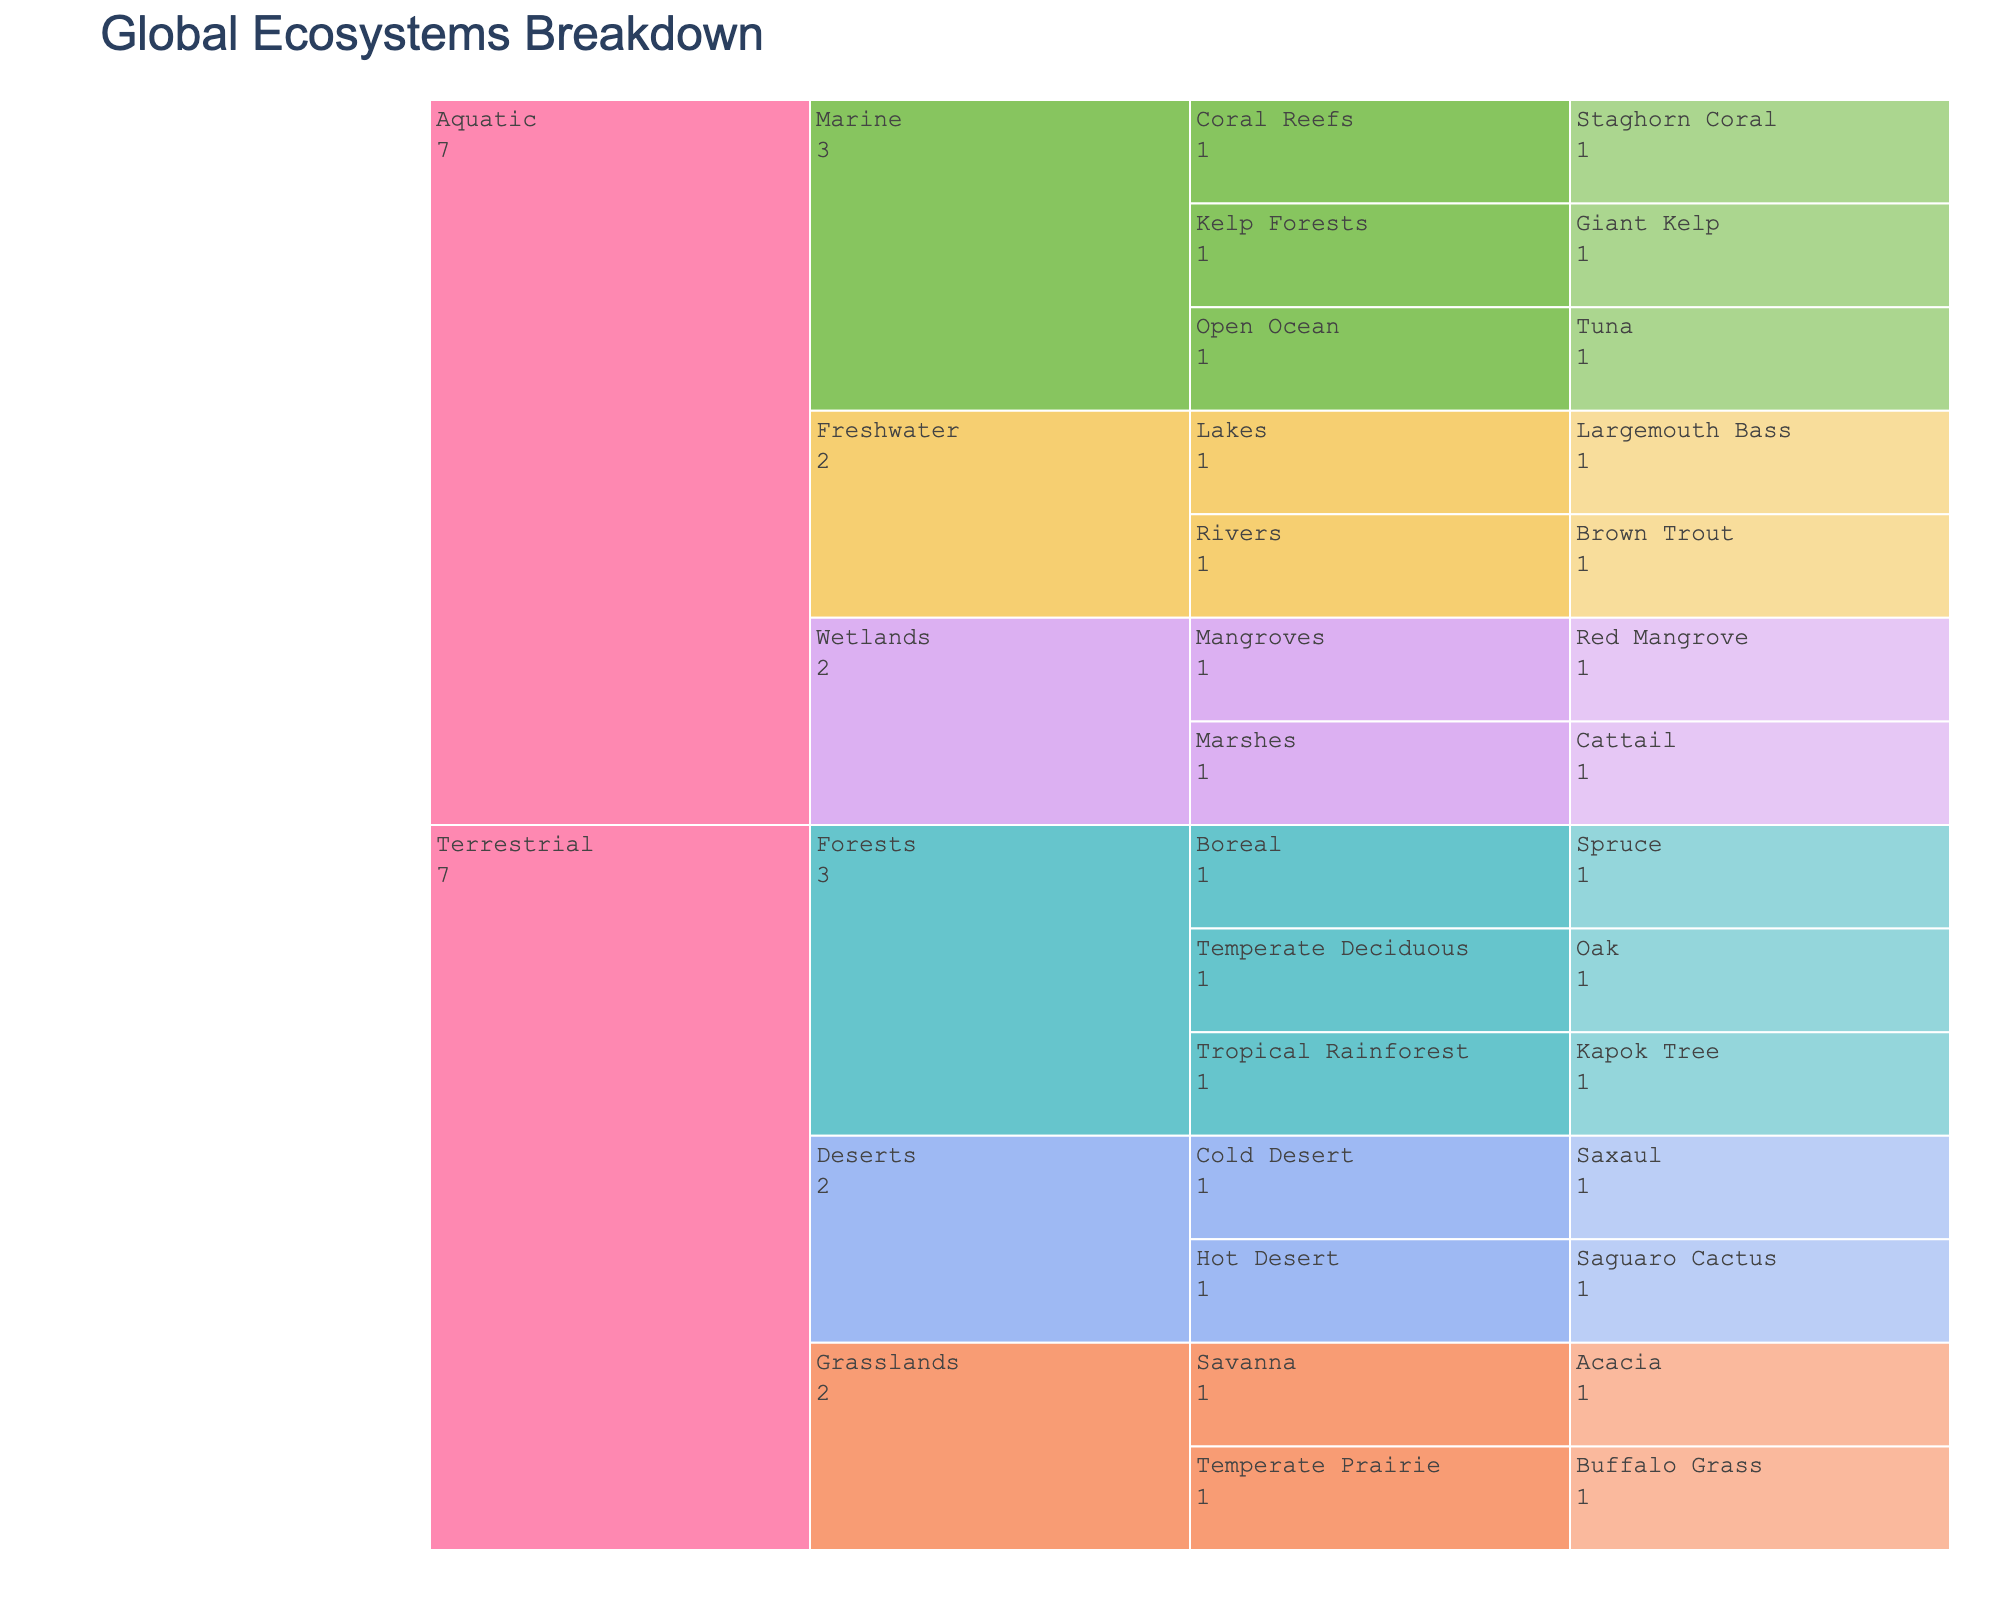What's the title of the figure? The title of the figure is usually prominently displayed at the top of the chart, and it provides a summary of what the chart is depicting. In this case, the title indicates the breakdown of global ecosystems by biome, habitat type, and dominant species.
Answer: Global Ecosystems Breakdown How many major ecosystems are presented in the figure? The Icicle Chart has distinct levels, with the topmost level representing the major ecosystems. From the data, we see there are two major ecosystems: Terrestrial and Aquatic.
Answer: 2 Which biome has the most habitat types listed? By examining the subdivisions under each biome within the Icicle Chart, you can count the number of different habitat types. For the Terrestrial ecosystem, Forests, Grasslands, and Deserts are the biomes, each with their subdivisions. In the Aquatic ecosystem, Freshwater, Marine, and Wetlands have subdivisions. Forests and Marine biomes each have three habitat types listed.
Answer: Forests and Marine What is the dominant species in temperate prairie habitats? To answer this, locate the Grasslands biome under the Terrestrial ecosystem in the Icicle Chart. From there, find the Temperate Prairie habitat. The figure will show the dominant species in each habitat type.
Answer: Buffalo Grass Which habitat type is common to both Terrestrial and Aquatic ecosystems? Analyze both ecosystems to find any shared habitat types. Terrestrial and Aquatic ecosystems have distinct habitat types, so there aren't shared habitats between these two ecosystems.
Answer: None How many habitat types are found within the Marine biome? The Marine biome is a subdivision under the Aquatic ecosystem in the Icicle Chart. By counting the distinct habitat types listed under Marine, we see there are three: Coral Reefs, Open Ocean, and Kelp Forests.
Answer: 3 Compare the number of habitat types in the Terrestrial Forests biome versus the Aquatic Freshwater biome. The Terrestrial Forests biome has three habitat types: Tropical Rainforest, Temperate Deciduous, and Boreal. The Aquatic Freshwater biome has two habitat types: Lakes and Rivers. Thus, the Forests biome has one more habitat type than the Freshwater biome.
Answer: Forests have 1 more habitat type What is the dominant species in the Desert biome of the Terrestrial ecosystem? The Desert biome in the Terrestrial ecosystem is shown with two habitat types: Hot Desert and Cold Desert. By identifying the dominant species in each of these habitats, we find Saguaro Cactus in Hot Desert and Saxaul in Cold Desert.
Answer: Saguaro Cactus and Saxaul What are the color patterns used to distinguish different biomes? The colors in the Icicle Chart are used to differentiate biomes visually. According to the color scheme from the provided code, each biome will be represented by a distinct color from a Pastel palette. Specific color names are not provided in the data.
Answer: Pastel colors How many levels of hierarchy are displayed in the Icicle Chart? The Icicle Chart typically has layers representing different levels of categorical data. From the data, there are four levels: Ecosystem, Biome, Habitat, and Dominant Species.
Answer: 4 